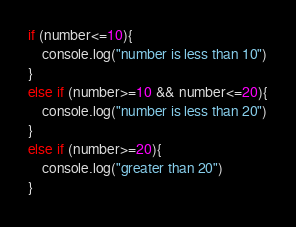Convert code to text. <code><loc_0><loc_0><loc_500><loc_500><_JavaScript_>if (number<=10){
    console.log("number is less than 10")
}
else if (number>=10 && number<=20){
    console.log("number is less than 20")
}
else if (number>=20){
    console.log("greater than 20")
}</code> 